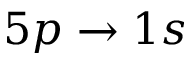<formula> <loc_0><loc_0><loc_500><loc_500>5 p \to 1 s</formula> 